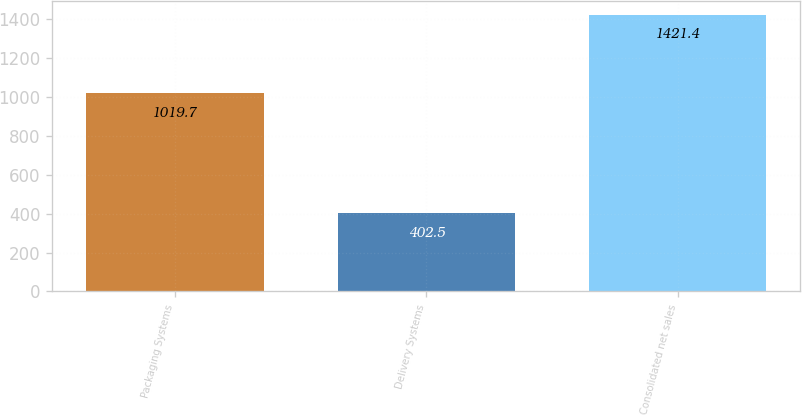Convert chart. <chart><loc_0><loc_0><loc_500><loc_500><bar_chart><fcel>Packaging Systems<fcel>Delivery Systems<fcel>Consolidated net sales<nl><fcel>1019.7<fcel>402.5<fcel>1421.4<nl></chart> 